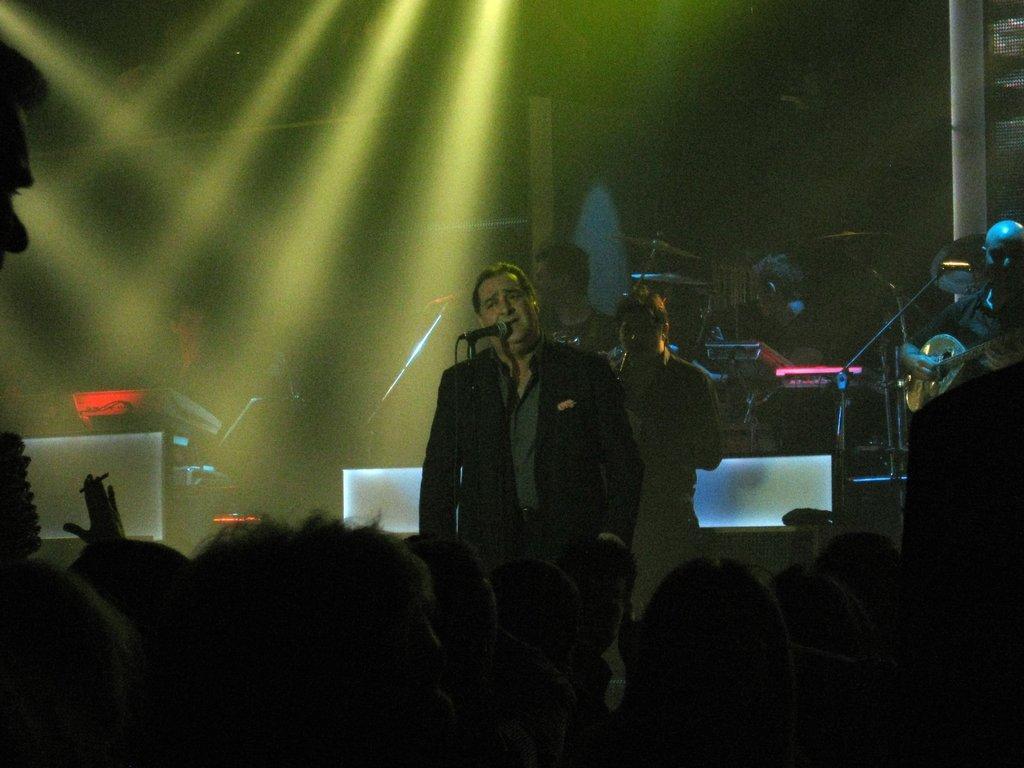Could you give a brief overview of what you see in this image? At the bottom of the image, we can see people. In the middle of the image, we can see a man is standing. He is wearing a coat. In front of the man, we can see a stand and mic. In the background, people are playing musical instruments. There is a pole in the right top of the image. 